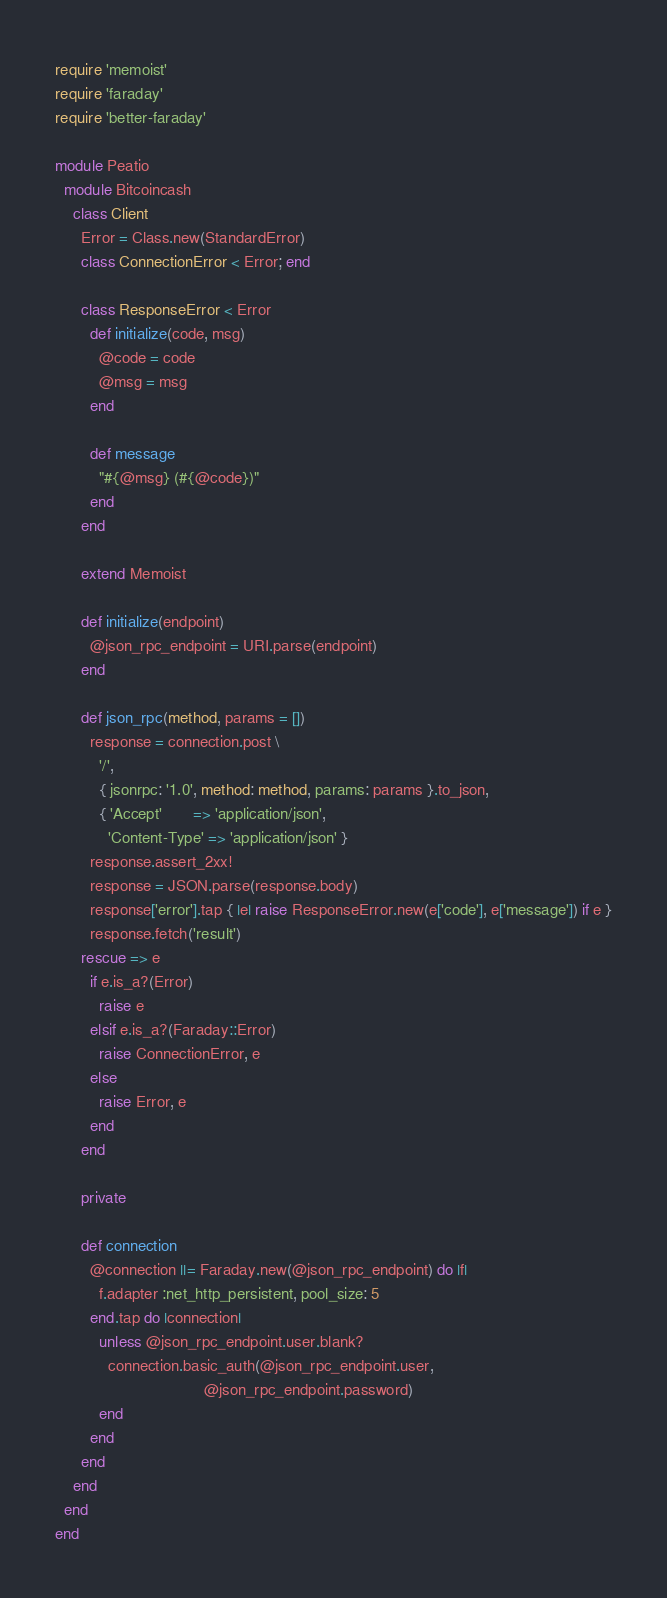Convert code to text. <code><loc_0><loc_0><loc_500><loc_500><_Ruby_>require 'memoist'
require 'faraday'
require 'better-faraday'

module Peatio
  module Bitcoincash
    class Client
      Error = Class.new(StandardError)
      class ConnectionError < Error; end

      class ResponseError < Error
        def initialize(code, msg)
          @code = code
          @msg = msg
        end

        def message
          "#{@msg} (#{@code})"
        end
      end

      extend Memoist

      def initialize(endpoint)
        @json_rpc_endpoint = URI.parse(endpoint)
      end

      def json_rpc(method, params = [])
        response = connection.post \
          '/',
          { jsonrpc: '1.0', method: method, params: params }.to_json,
          { 'Accept'       => 'application/json',
            'Content-Type' => 'application/json' }
        response.assert_2xx!
        response = JSON.parse(response.body)
        response['error'].tap { |e| raise ResponseError.new(e['code'], e['message']) if e }
        response.fetch('result')
      rescue => e
        if e.is_a?(Error)
          raise e
        elsif e.is_a?(Faraday::Error)
          raise ConnectionError, e
        else
          raise Error, e
        end
      end

      private

      def connection
        @connection ||= Faraday.new(@json_rpc_endpoint) do |f|
          f.adapter :net_http_persistent, pool_size: 5
        end.tap do |connection|
          unless @json_rpc_endpoint.user.blank?
            connection.basic_auth(@json_rpc_endpoint.user,
                                  @json_rpc_endpoint.password)
          end
        end
      end
    end
  end
end
</code> 